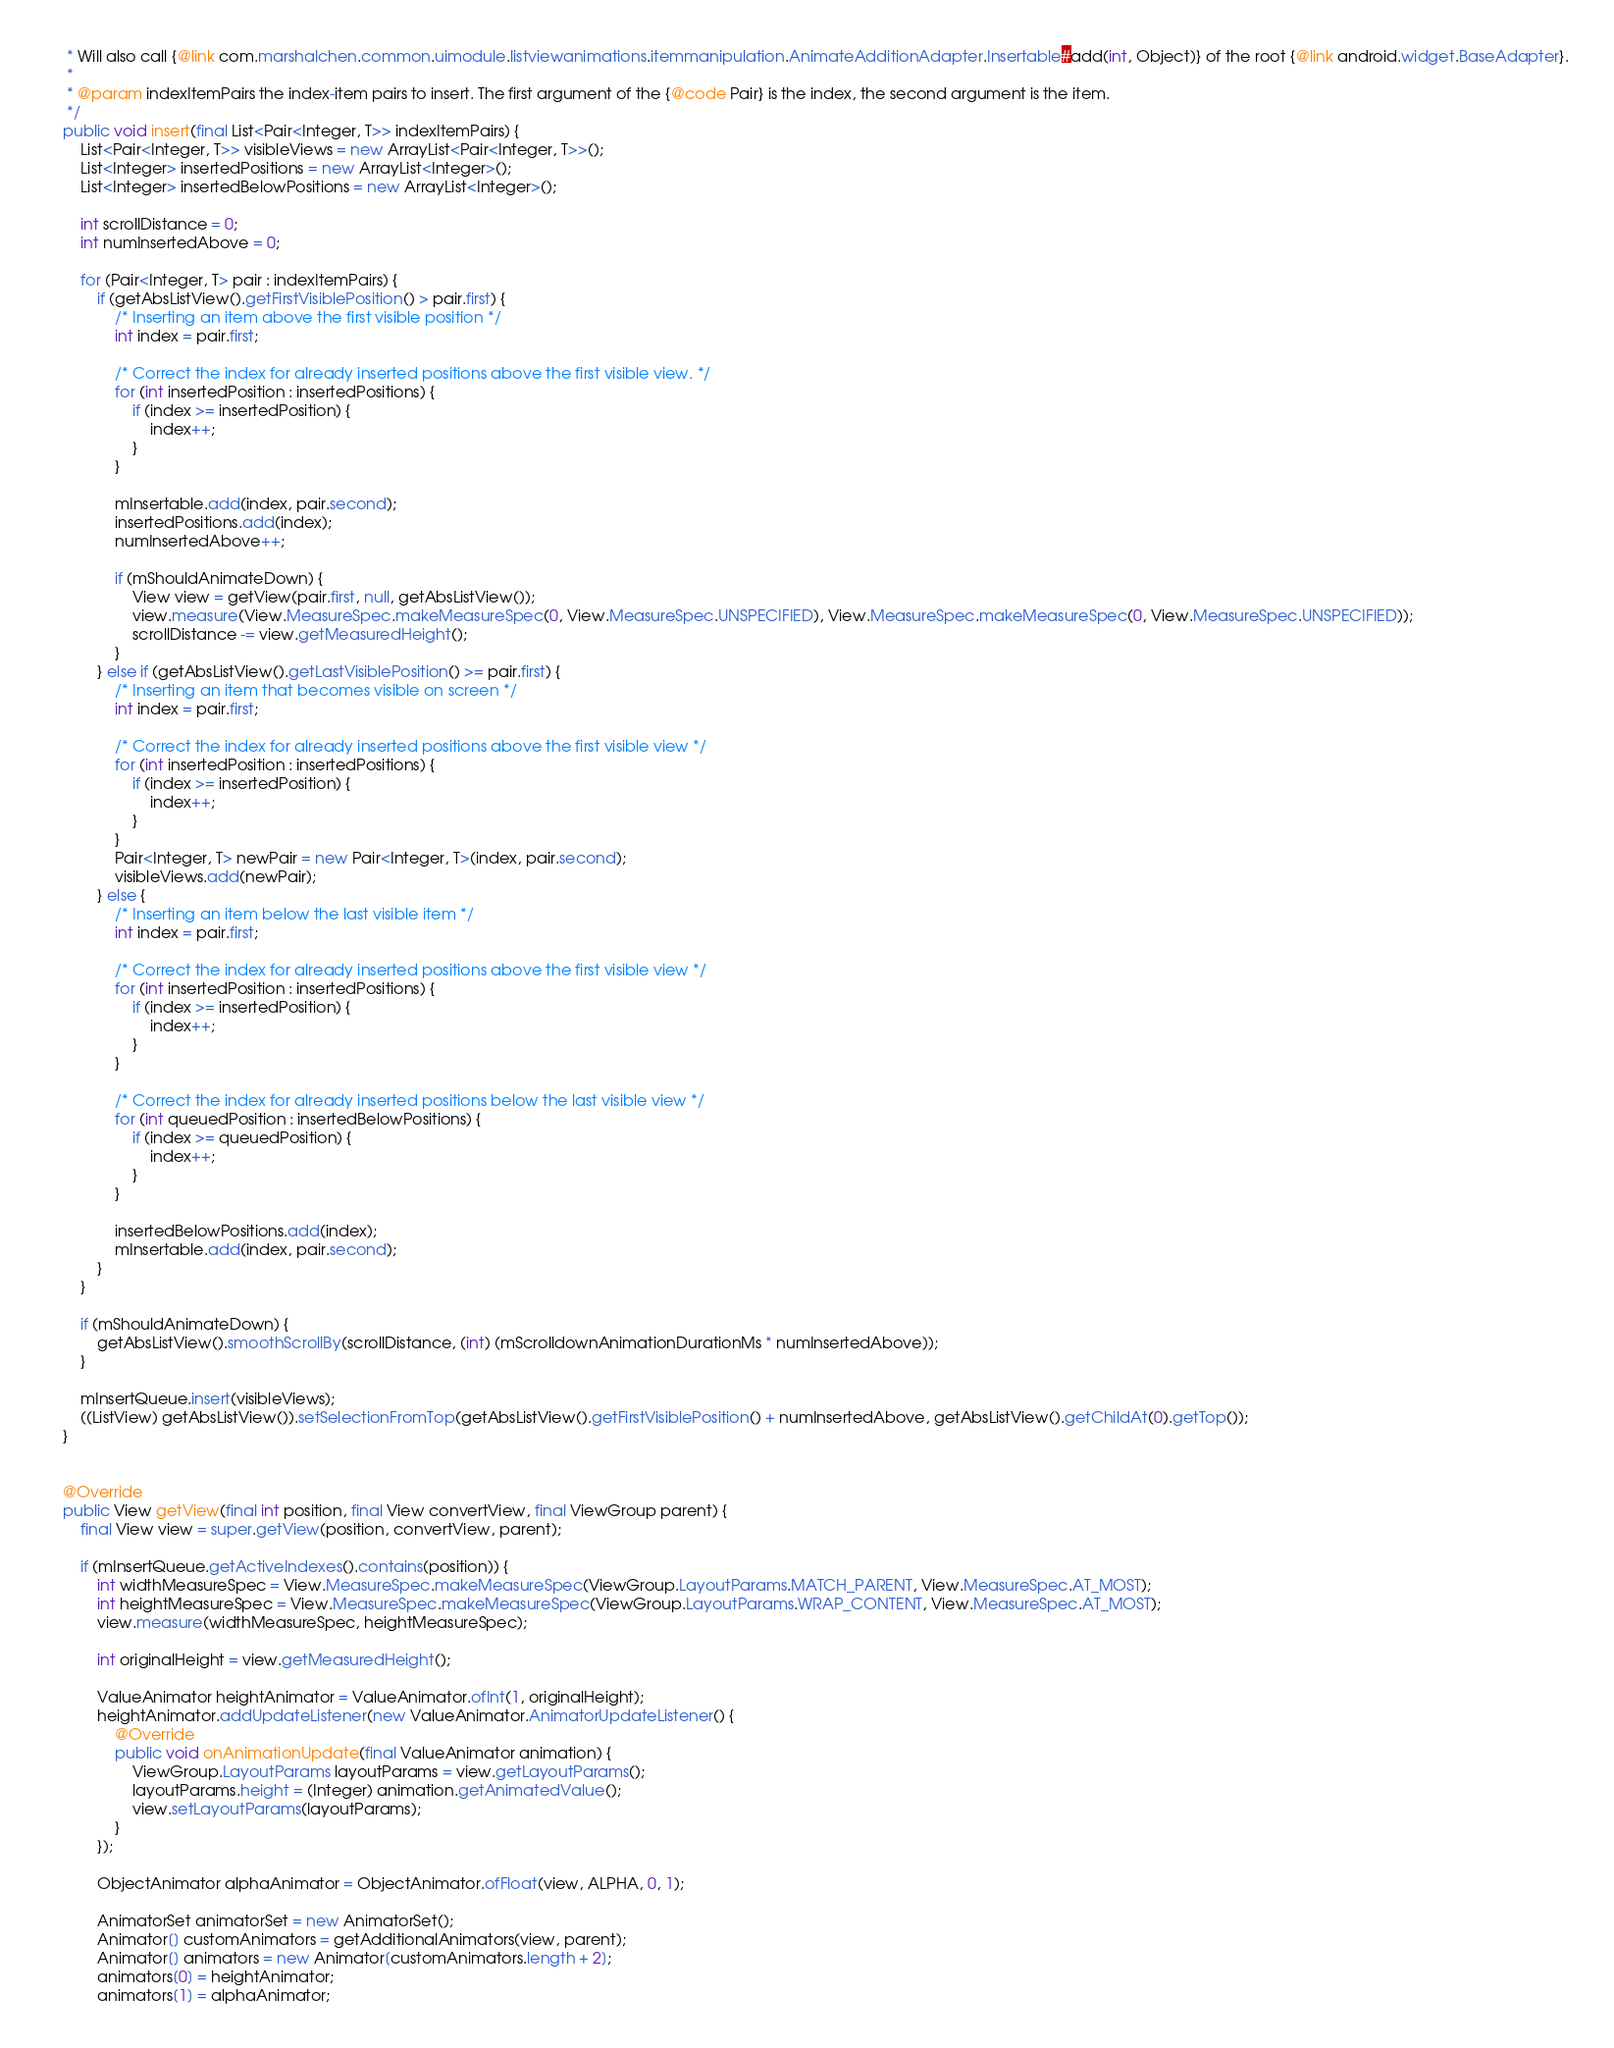<code> <loc_0><loc_0><loc_500><loc_500><_Java_>     * Will also call {@link com.marshalchen.common.uimodule.listviewanimations.itemmanipulation.AnimateAdditionAdapter.Insertable#add(int, Object)} of the root {@link android.widget.BaseAdapter}.
     *
     * @param indexItemPairs the index-item pairs to insert. The first argument of the {@code Pair} is the index, the second argument is the item.
     */
    public void insert(final List<Pair<Integer, T>> indexItemPairs) {
        List<Pair<Integer, T>> visibleViews = new ArrayList<Pair<Integer, T>>();
        List<Integer> insertedPositions = new ArrayList<Integer>();
        List<Integer> insertedBelowPositions = new ArrayList<Integer>();

        int scrollDistance = 0;
        int numInsertedAbove = 0;

        for (Pair<Integer, T> pair : indexItemPairs) {
            if (getAbsListView().getFirstVisiblePosition() > pair.first) {
                /* Inserting an item above the first visible position */
                int index = pair.first;

                /* Correct the index for already inserted positions above the first visible view. */
                for (int insertedPosition : insertedPositions) {
                    if (index >= insertedPosition) {
                        index++;
                    }
                }

                mInsertable.add(index, pair.second);
                insertedPositions.add(index);
                numInsertedAbove++;

                if (mShouldAnimateDown) {
                    View view = getView(pair.first, null, getAbsListView());
                    view.measure(View.MeasureSpec.makeMeasureSpec(0, View.MeasureSpec.UNSPECIFIED), View.MeasureSpec.makeMeasureSpec(0, View.MeasureSpec.UNSPECIFIED));
                    scrollDistance -= view.getMeasuredHeight();
                }
            } else if (getAbsListView().getLastVisiblePosition() >= pair.first) {
                /* Inserting an item that becomes visible on screen */
                int index = pair.first;

                /* Correct the index for already inserted positions above the first visible view */
                for (int insertedPosition : insertedPositions) {
                    if (index >= insertedPosition) {
                        index++;
                    }
                }
                Pair<Integer, T> newPair = new Pair<Integer, T>(index, pair.second);
                visibleViews.add(newPair);
            } else {
                /* Inserting an item below the last visible item */
                int index = pair.first;

                /* Correct the index for already inserted positions above the first visible view */
                for (int insertedPosition : insertedPositions) {
                    if (index >= insertedPosition) {
                        index++;
                    }
                }

                /* Correct the index for already inserted positions below the last visible view */
                for (int queuedPosition : insertedBelowPositions) {
                    if (index >= queuedPosition) {
                        index++;
                    }
                }

                insertedBelowPositions.add(index);
                mInsertable.add(index, pair.second);
            }
        }

        if (mShouldAnimateDown) {
            getAbsListView().smoothScrollBy(scrollDistance, (int) (mScrolldownAnimationDurationMs * numInsertedAbove));
        }

        mInsertQueue.insert(visibleViews);
        ((ListView) getAbsListView()).setSelectionFromTop(getAbsListView().getFirstVisiblePosition() + numInsertedAbove, getAbsListView().getChildAt(0).getTop());
    }


    @Override
    public View getView(final int position, final View convertView, final ViewGroup parent) {
        final View view = super.getView(position, convertView, parent);

        if (mInsertQueue.getActiveIndexes().contains(position)) {
            int widthMeasureSpec = View.MeasureSpec.makeMeasureSpec(ViewGroup.LayoutParams.MATCH_PARENT, View.MeasureSpec.AT_MOST);
            int heightMeasureSpec = View.MeasureSpec.makeMeasureSpec(ViewGroup.LayoutParams.WRAP_CONTENT, View.MeasureSpec.AT_MOST);
            view.measure(widthMeasureSpec, heightMeasureSpec);

            int originalHeight = view.getMeasuredHeight();

            ValueAnimator heightAnimator = ValueAnimator.ofInt(1, originalHeight);
            heightAnimator.addUpdateListener(new ValueAnimator.AnimatorUpdateListener() {
                @Override
                public void onAnimationUpdate(final ValueAnimator animation) {
                    ViewGroup.LayoutParams layoutParams = view.getLayoutParams();
                    layoutParams.height = (Integer) animation.getAnimatedValue();
                    view.setLayoutParams(layoutParams);
                }
            });

            ObjectAnimator alphaAnimator = ObjectAnimator.ofFloat(view, ALPHA, 0, 1);

            AnimatorSet animatorSet = new AnimatorSet();
            Animator[] customAnimators = getAdditionalAnimators(view, parent);
            Animator[] animators = new Animator[customAnimators.length + 2];
            animators[0] = heightAnimator;
            animators[1] = alphaAnimator;</code> 